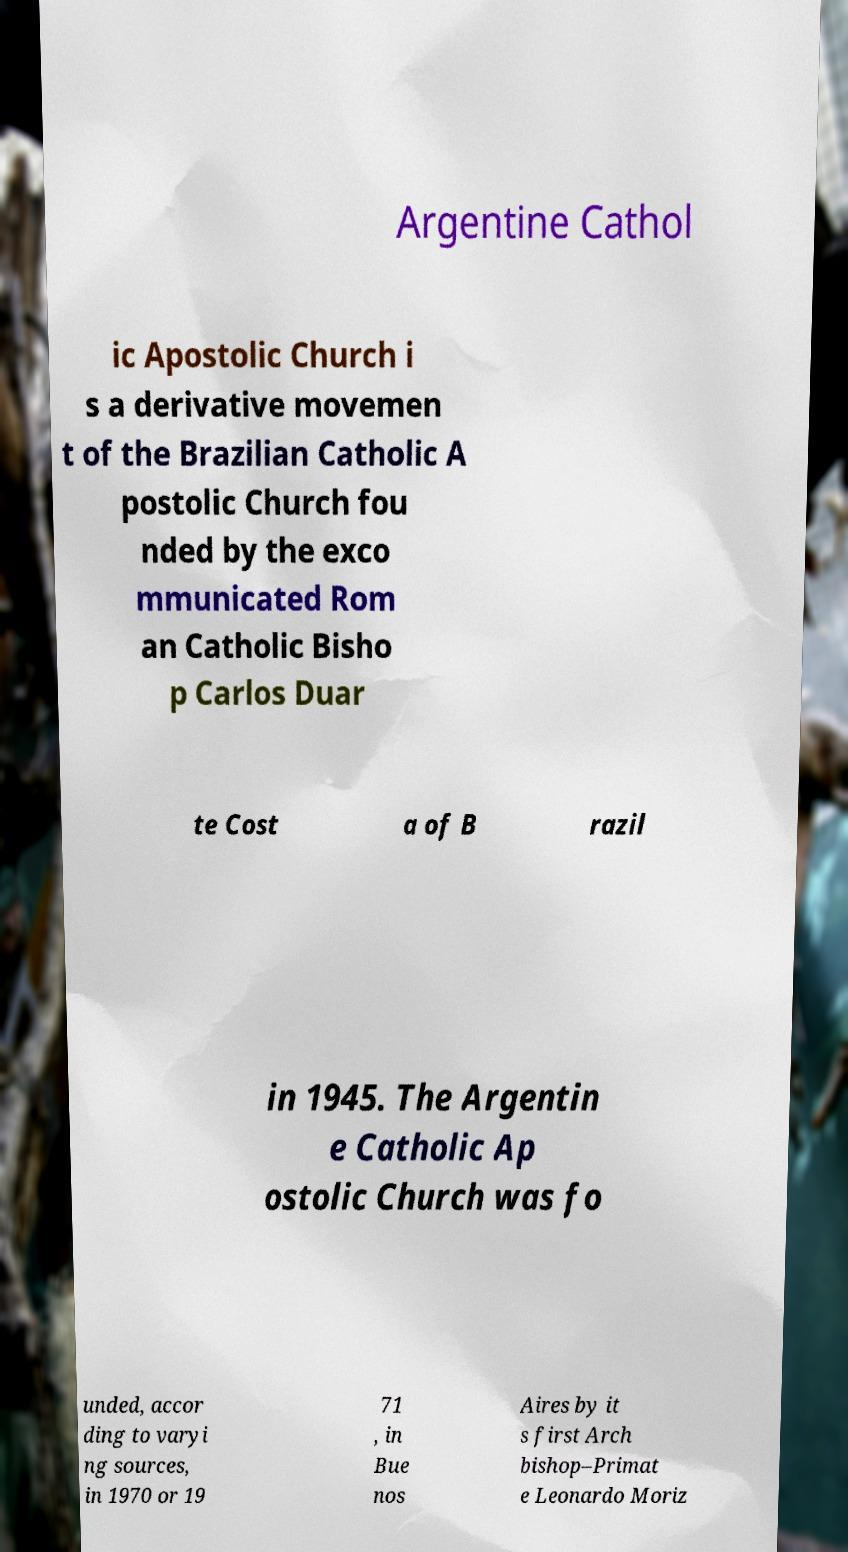Could you extract and type out the text from this image? Argentine Cathol ic Apostolic Church i s a derivative movemen t of the Brazilian Catholic A postolic Church fou nded by the exco mmunicated Rom an Catholic Bisho p Carlos Duar te Cost a of B razil in 1945. The Argentin e Catholic Ap ostolic Church was fo unded, accor ding to varyi ng sources, in 1970 or 19 71 , in Bue nos Aires by it s first Arch bishop–Primat e Leonardo Moriz 